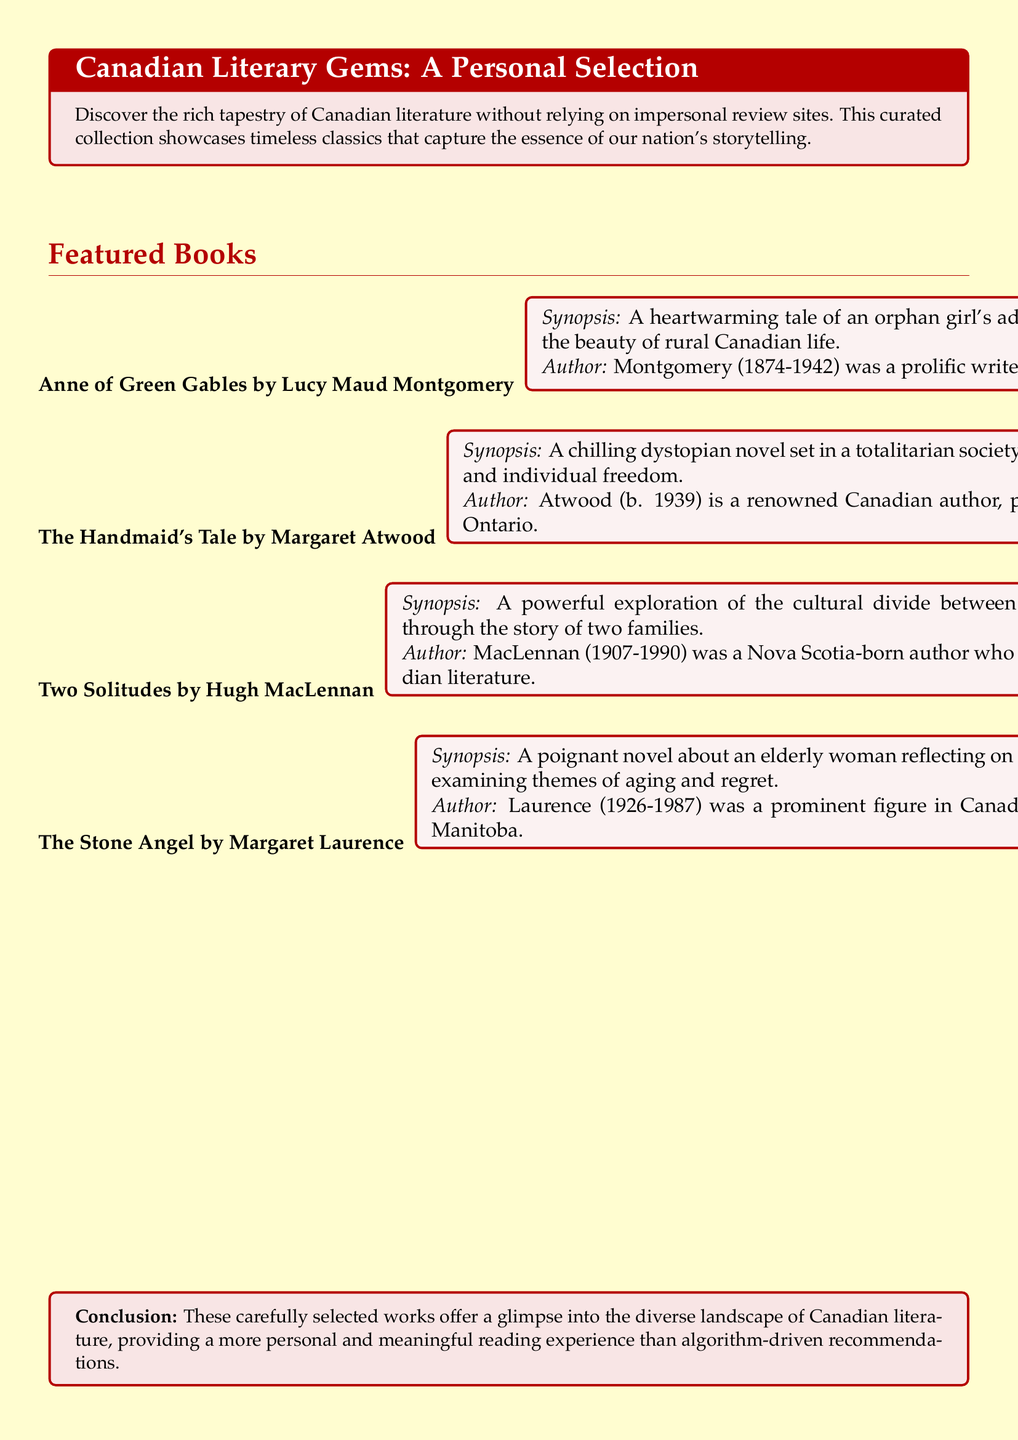What is the title of the first featured book? The title of the first featured book is "Anne of Green Gables".
Answer: Anne of Green Gables Who is the author of "The Handmaid's Tale"? The author of "The Handmaid's Tale" is Margaret Atwood.
Answer: Margaret Atwood What year was Lucy Maud Montgomery born? Lucy Maud Montgomery was born in 1874.
Answer: 1874 What is the main theme explored in "Two Solitudes"? The main theme explored in "Two Solitudes" is the cultural divide between English and French Canada.
Answer: Cultural divide How many authors are featured in the document? The document features a total of four authors.
Answer: Four Which author's work is set in Prince Edward Island? The author's work set in Prince Edward Island is Lucy Maud Montgomery.
Answer: Lucy Maud Montgomery What significant societal theme does "The Handmaid's Tale" address? "The Handmaid's Tale" addresses the theme of women's rights.
Answer: Women's rights In what year did Margaret Laurence pass away? Margaret Laurence passed away in 1987.
Answer: 1987 What type of literary work is "The Stone Angel"? "The Stone Angel" is a novel.
Answer: Novel 